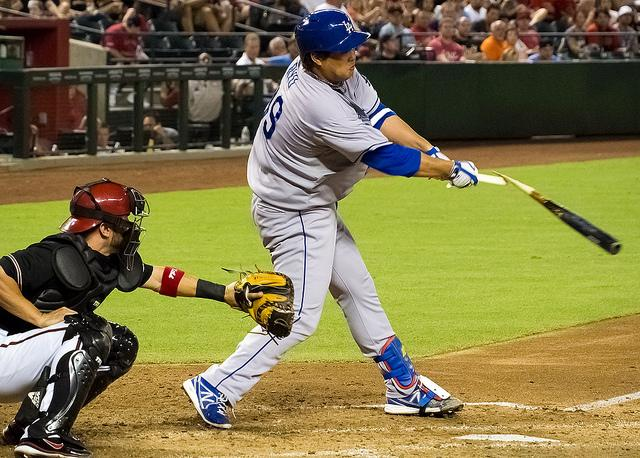What team is the batter playing for? Please explain your reasoning. dodgers. He is playing for the dodgers. 